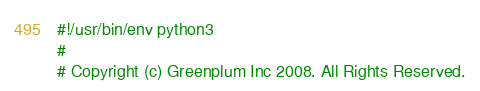Convert code to text. <code><loc_0><loc_0><loc_500><loc_500><_Python_>#!/usr/bin/env python3
#
# Copyright (c) Greenplum Inc 2008. All Rights Reserved.</code> 